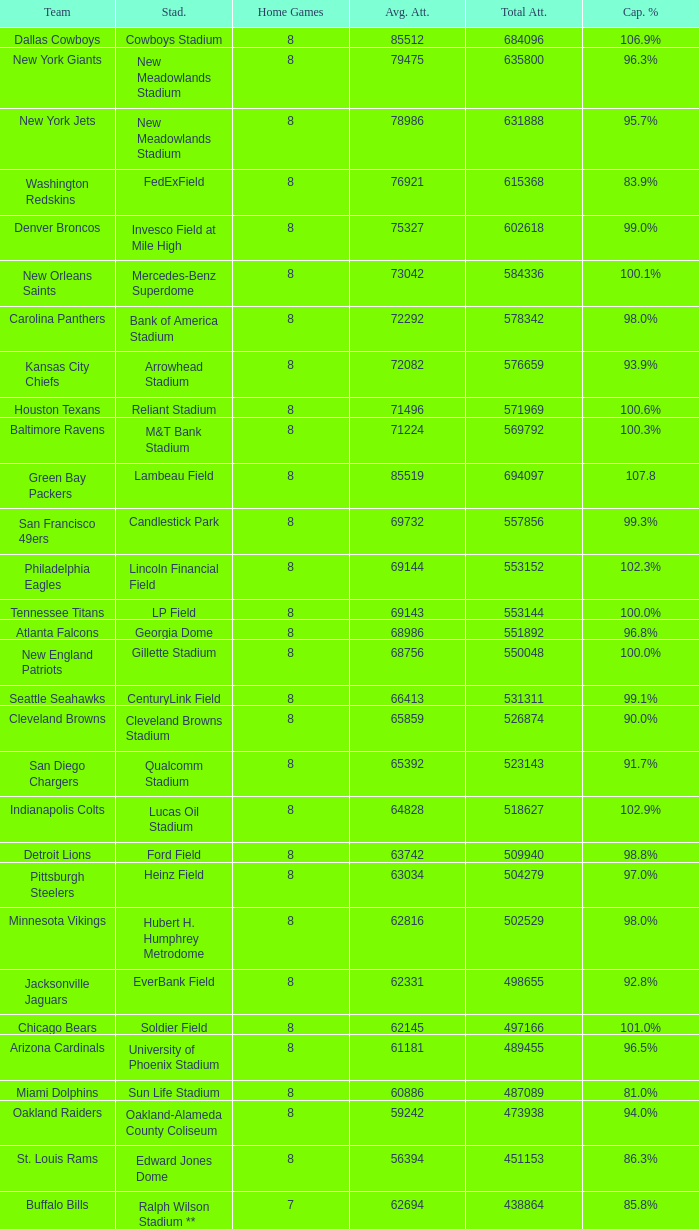How many home games are listed when the average attendance is 79475? 1.0. 